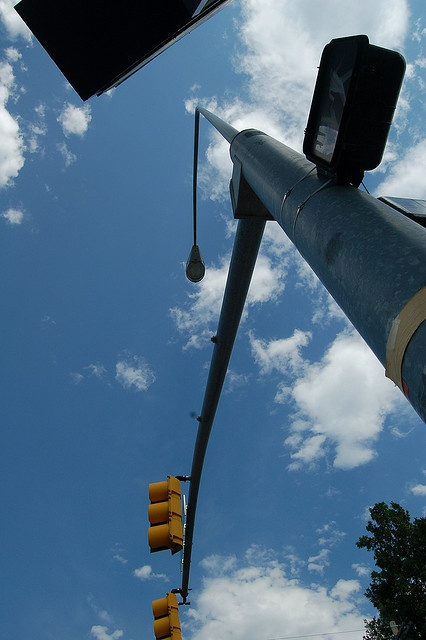Describe the objects in this image and their specific colors. I can see traffic light in darkgray, black, gray, blue, and teal tones, traffic light in darkgray, olive, maroon, and black tones, and traffic light in darkgray, olive, maroon, and black tones in this image. 